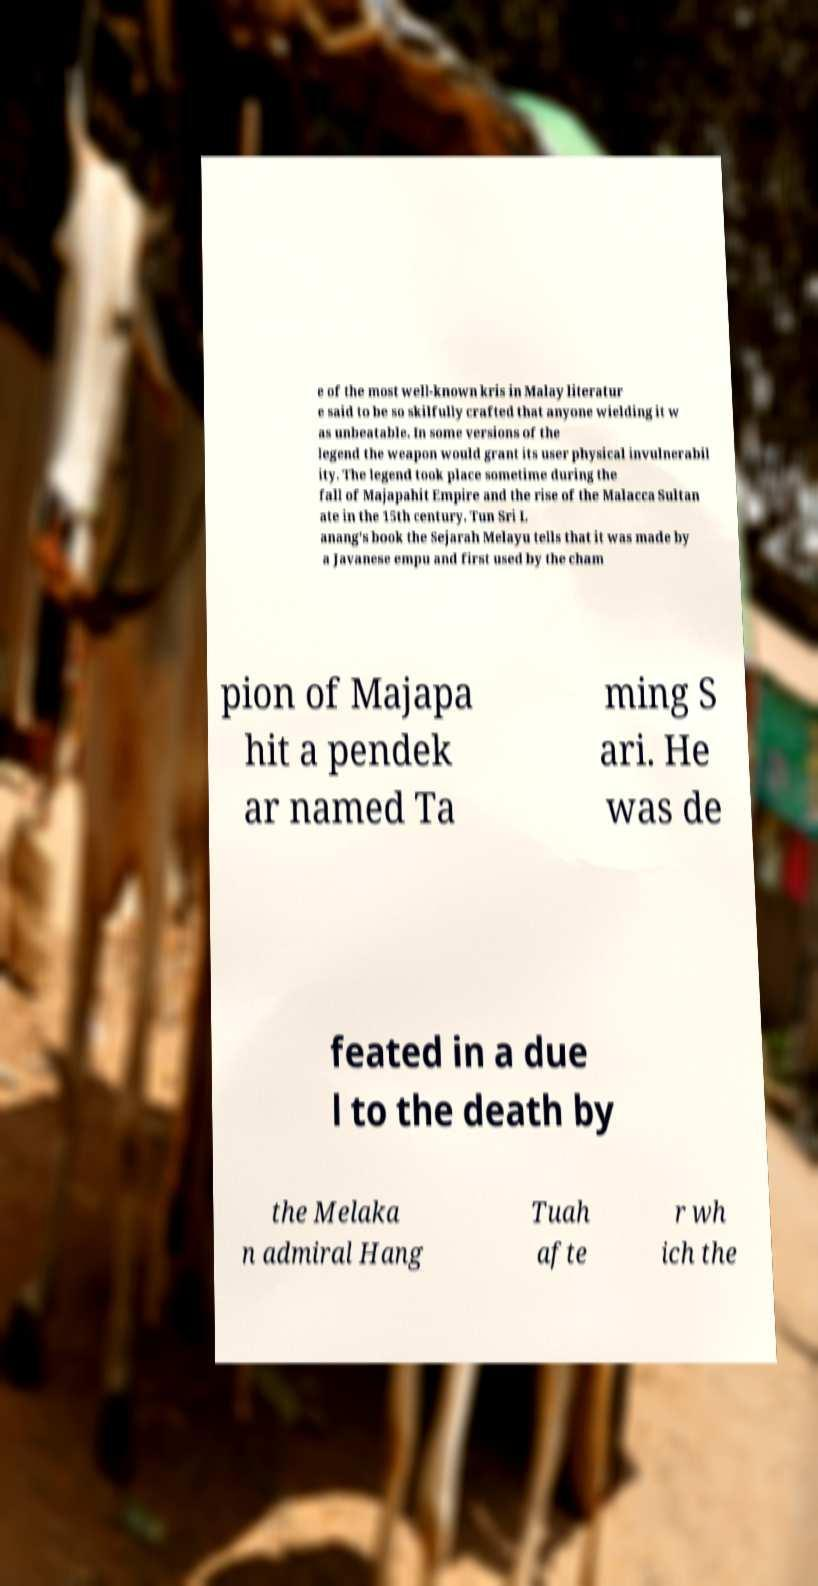Could you assist in decoding the text presented in this image and type it out clearly? e of the most well-known kris in Malay literatur e said to be so skilfully crafted that anyone wielding it w as unbeatable. In some versions of the legend the weapon would grant its user physical invulnerabil ity. The legend took place sometime during the fall of Majapahit Empire and the rise of the Malacca Sultan ate in the 15th century. Tun Sri L anang's book the Sejarah Melayu tells that it was made by a Javanese empu and first used by the cham pion of Majapa hit a pendek ar named Ta ming S ari. He was de feated in a due l to the death by the Melaka n admiral Hang Tuah afte r wh ich the 